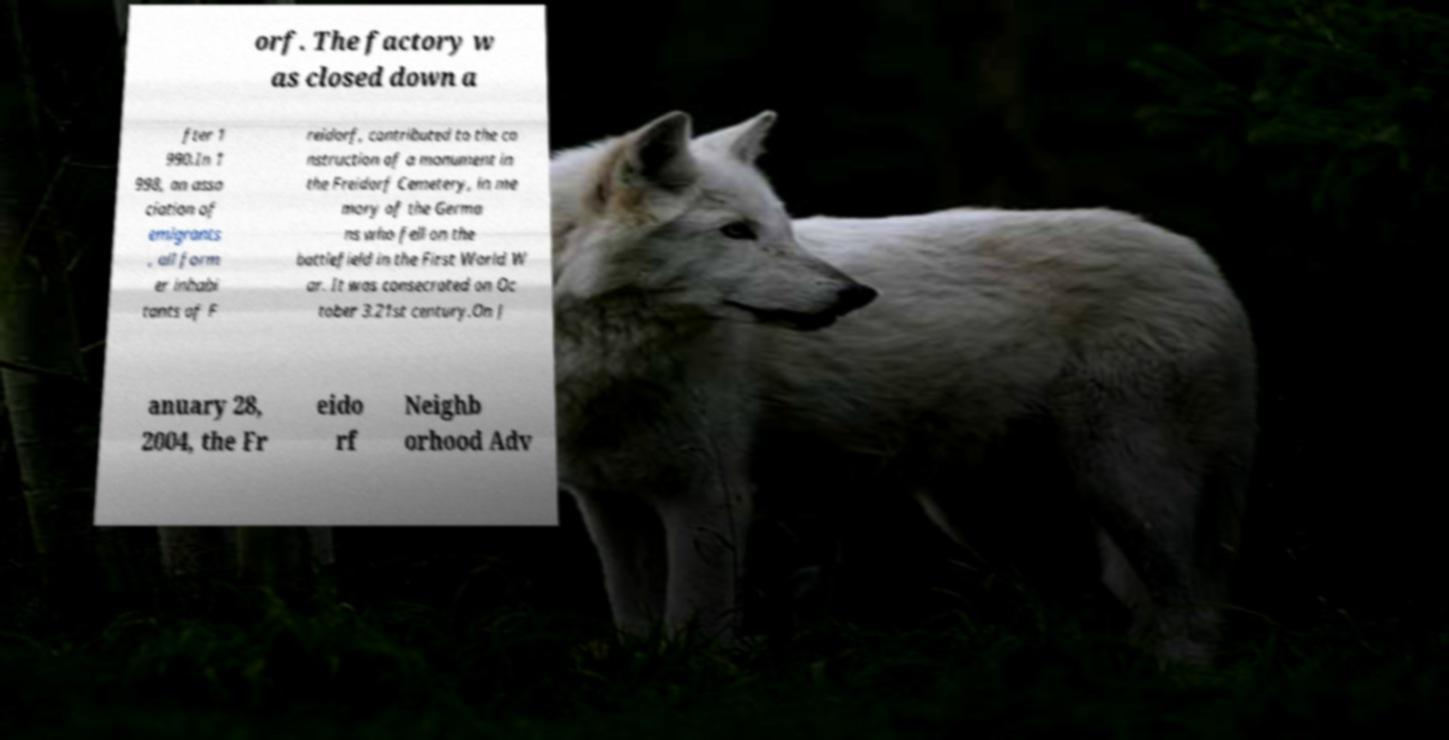For documentation purposes, I need the text within this image transcribed. Could you provide that? orf. The factory w as closed down a fter 1 990.In 1 998, an asso ciation of emigrants , all form er inhabi tants of F reidorf, contributed to the co nstruction of a monument in the Freidorf Cemetery, in me mory of the Germa ns who fell on the battlefield in the First World W ar. It was consecrated on Oc tober 3.21st century.On J anuary 28, 2004, the Fr eido rf Neighb orhood Adv 